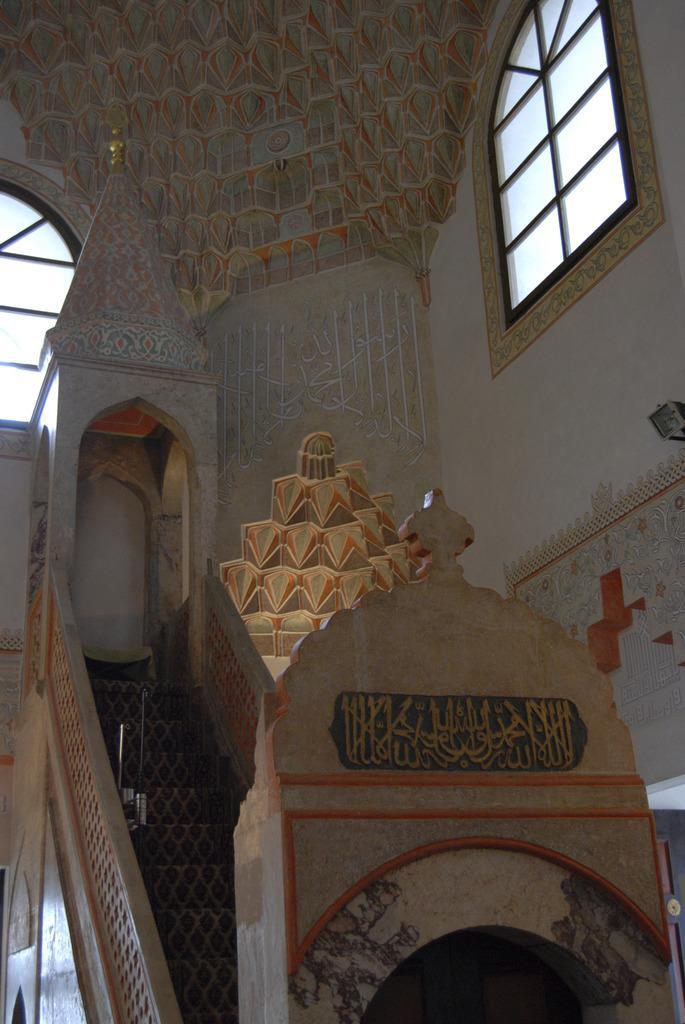In one or two sentences, can you explain what this image depicts? In the picture I can see wall which has windows. Here I can see steps and some other objects. 